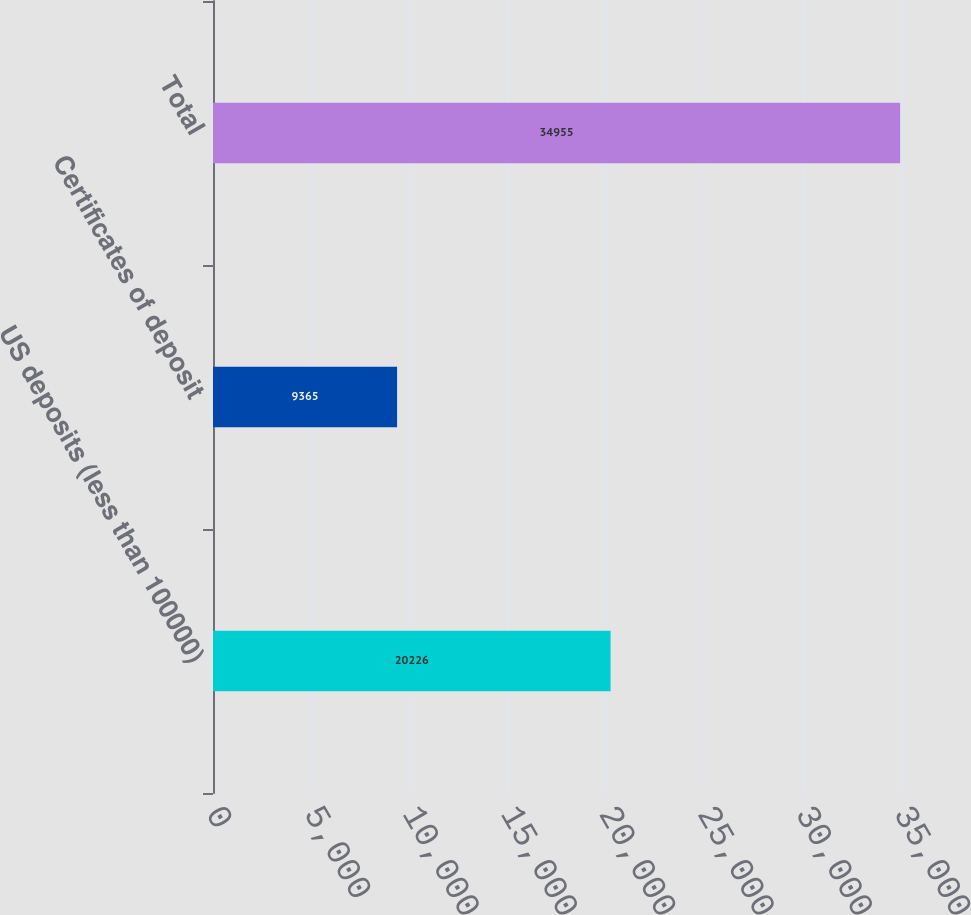Convert chart to OTSL. <chart><loc_0><loc_0><loc_500><loc_500><bar_chart><fcel>US deposits (less than 100000)<fcel>Certificates of deposit<fcel>Total<nl><fcel>20226<fcel>9365<fcel>34955<nl></chart> 